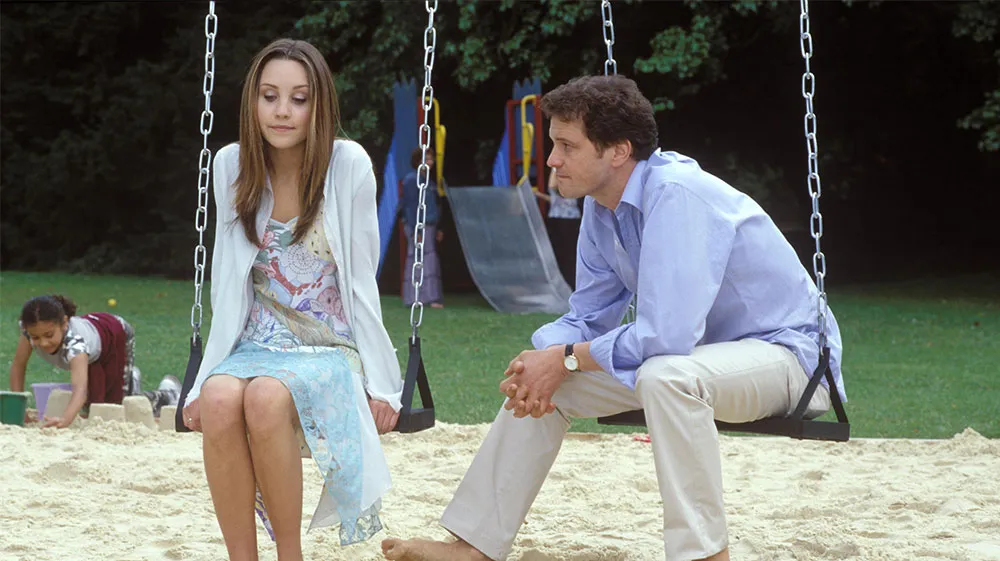Describe the emotions that might be conveyed by the individuals on the swings. The individuals on the swings appear to be engaged in a meaningful conversation. The woman's expression seems introspective and possibly contemplative, as she gazes downward. This might suggest she is sharing something personal or emotionally significant. The man, leaning forward with his hands clasped and looking towards her attentively, conveys a sense of empathy and concern. This suggests that he is either listening intently or offering support. The relaxed yet serious nature of their posture implies that their conversation is profound and possibly dealing with important matters. The overall atmosphere suggests a combination of introspection, empathy, and understanding between the two. What might have led to this deep conversation at the park? There could be numerous scenarios that led to this deep conversation at the park. Perhaps the woman was seeking solace and advice regarding a significant life decision or challenge. The park, with its peaceful and open environment, provides a perfect backdrop for such heartfelt discussions away from the hustle and bustle of daily life. It could also be a chance for them to reconnect after being apart, sharing experiences and emotions that have transpired in their lives recently. The presence of children playing in the background adds a layer of nostalgia, potentially reminding them of simpler times and prompting reflections on personal growth and choices. Imagine a creative scenario where the two individuals are discussing something magical. What could it be? Imagine that the two individuals on the swings are actually discussing a secret they discovered - a hidden world within the park. They are keepers of a magical realm that can only be accessed through a specific sequence of swings and jumps under the full moon. In this realm, they are guardians of ancient wisdom and fantastical creatures. Their conversation revolves around a looming threat from a dark force trying to breach their world, and they are strategizing on how to protect it. The woman's contemplative look signifies her concern over a recent disturbance in the magical realm, while the man's focused expression hints at his determination to safeguard the enchantment they have sworn to protect. Children playing nearby, unaware of the hidden magic, symbolize the innocence and joy that the guardians strive to preserve. Describe a scenario where the woman is explaining a new project she's passionate about. The woman enthusiastically explains a new community project she's spearheading, aimed at transforming the local playground into a more inclusive and engaging space for children of all abilities. She's sharing her vision of installing new, accessible play equipment and organizing creative workshops for children to explore their talents. Her eyes light up as she talks about the potential positive impact on the neighborhood, and she describes the support she's already garnered from local businesses and residents. The man listens attentively, offering suggestions and expressing admiration for her dedication and innovative ideas. Their conversation is filled with mutual respect and excitement, embodying a collaborative spirit and shared commitment to community improvement. In a very brief scenario, describe a possible reason for their serious conversation. The two individuals are discussing an important family matter, perhaps concerning the health of a loved one. The park's tranquil surroundings provide a comforting space for them to express their fears and hopes. 